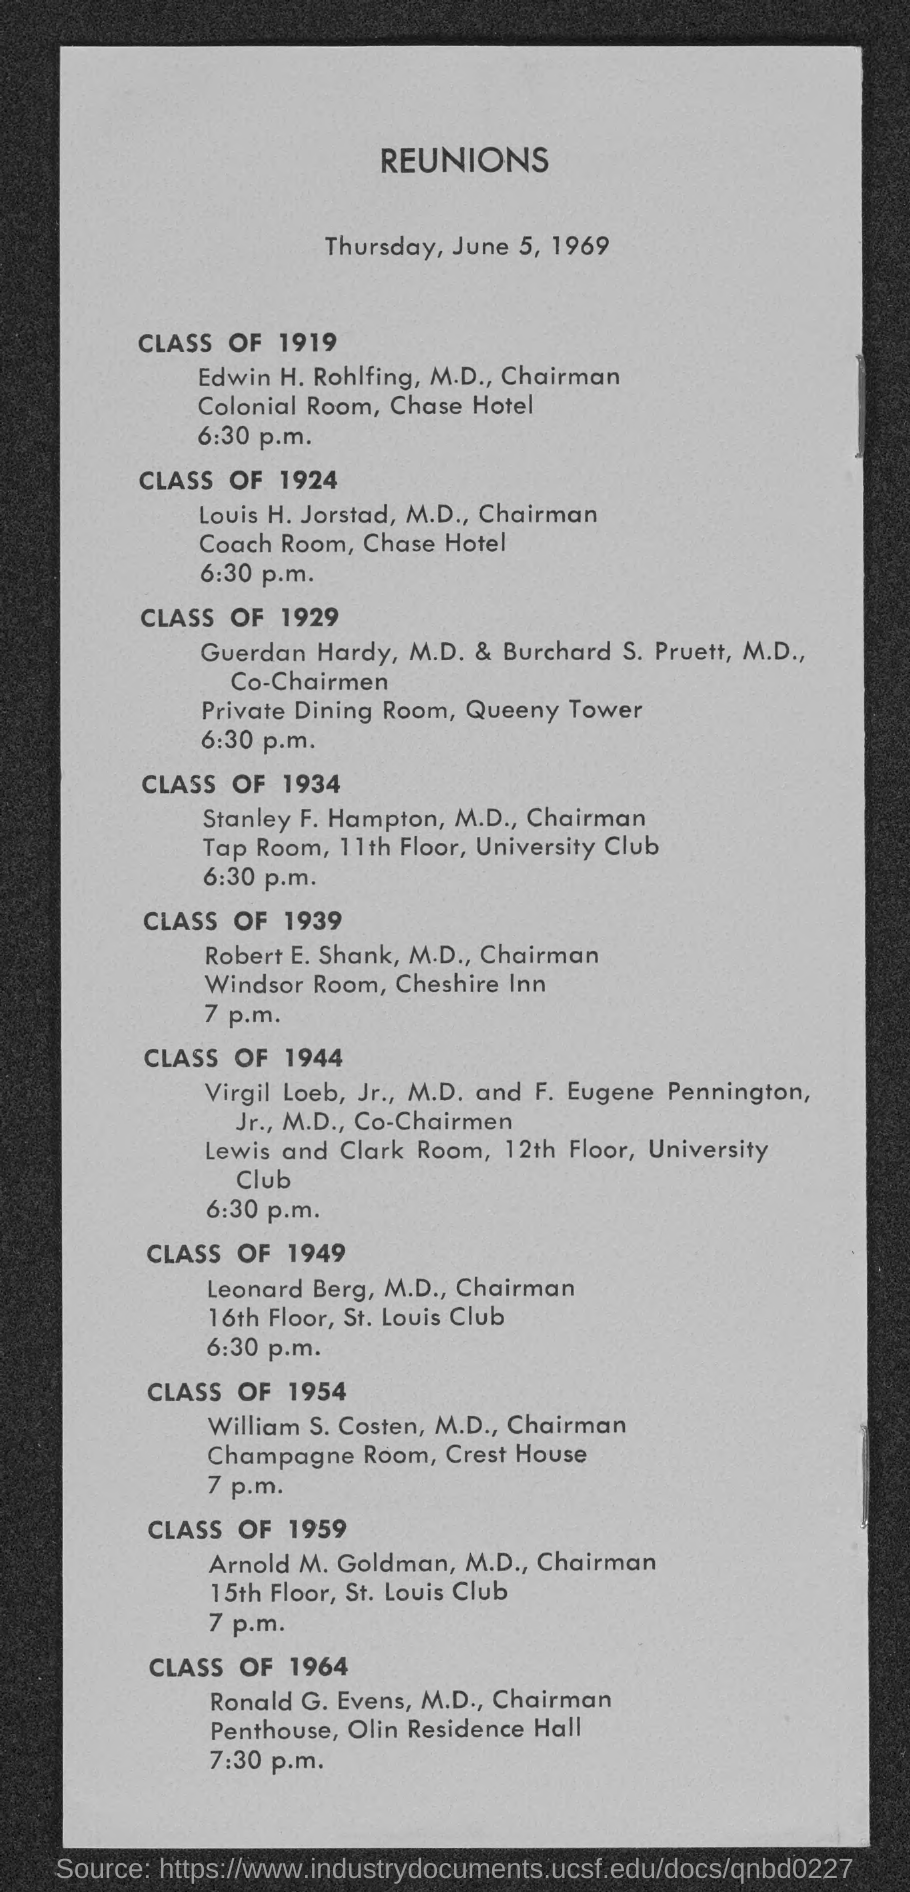What is the venue for class of 1919?
Give a very brief answer. Colonial room. What is the venue for class 1924
Your answer should be very brief. Coach room. What is the venue for class of 1929?
Provide a short and direct response. Private dining room. What is the venue for class of 1939?
Offer a very short reply. Windsor room, cheshire inn. What is the venue for class of 1954?
Your response must be concise. Champagne room, Crest House. 